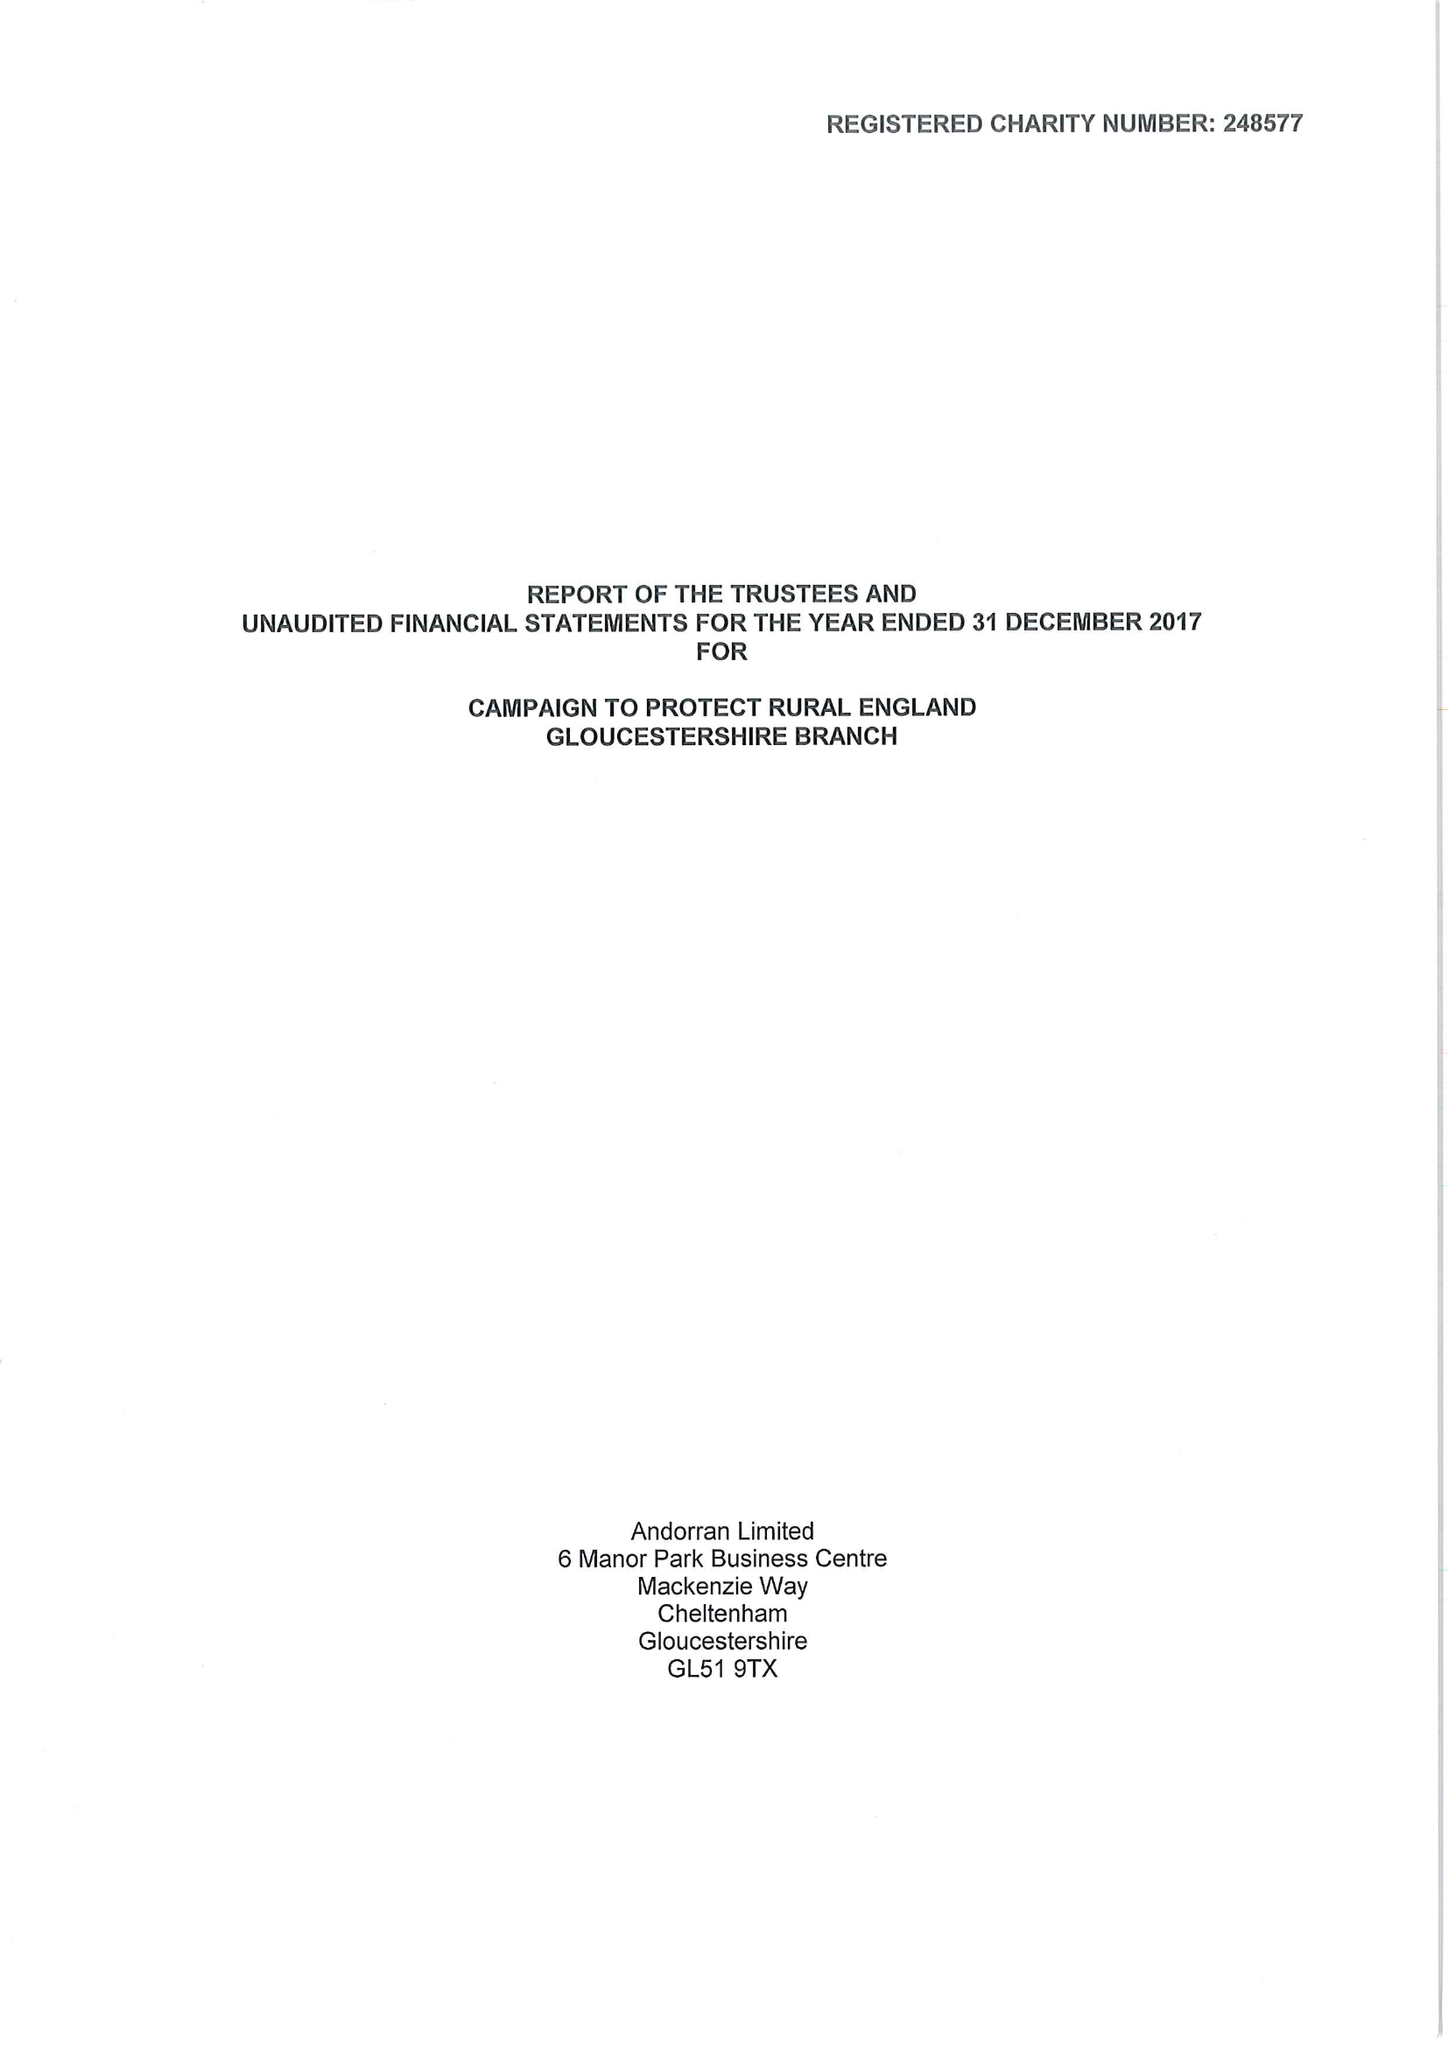What is the value for the address__post_town?
Answer the question using a single word or phrase. GLOUCESTER 